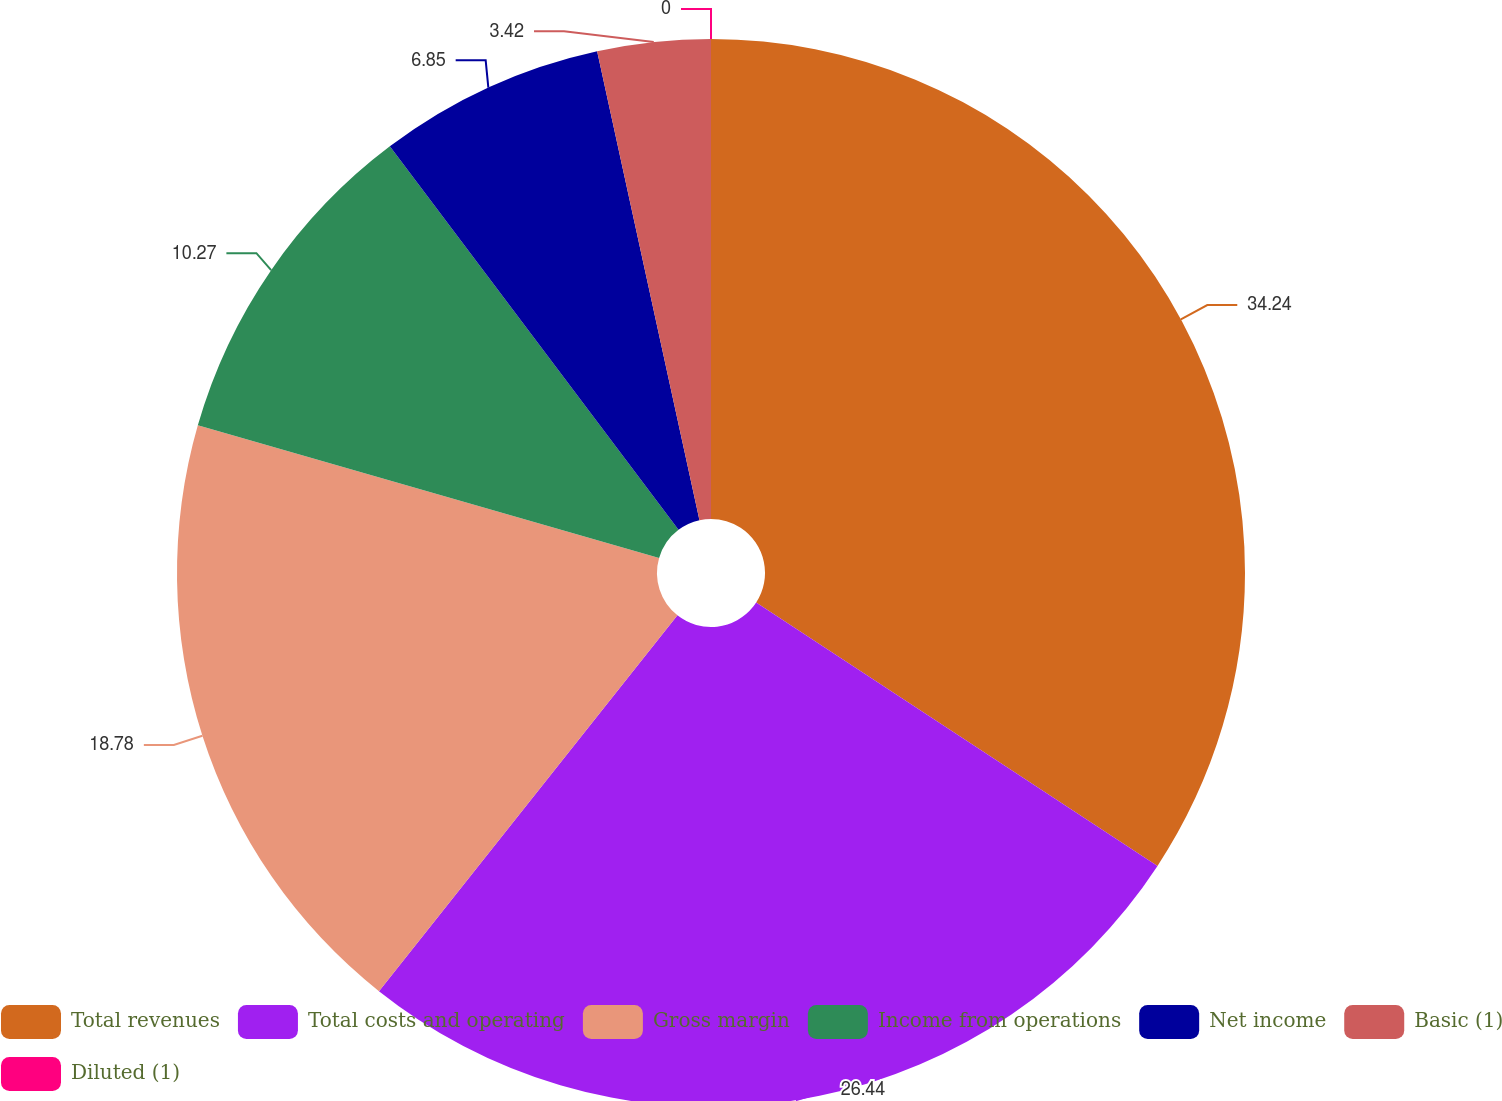Convert chart to OTSL. <chart><loc_0><loc_0><loc_500><loc_500><pie_chart><fcel>Total revenues<fcel>Total costs and operating<fcel>Gross margin<fcel>Income from operations<fcel>Net income<fcel>Basic (1)<fcel>Diluted (1)<nl><fcel>34.24%<fcel>26.44%<fcel>18.78%<fcel>10.27%<fcel>6.85%<fcel>3.42%<fcel>0.0%<nl></chart> 